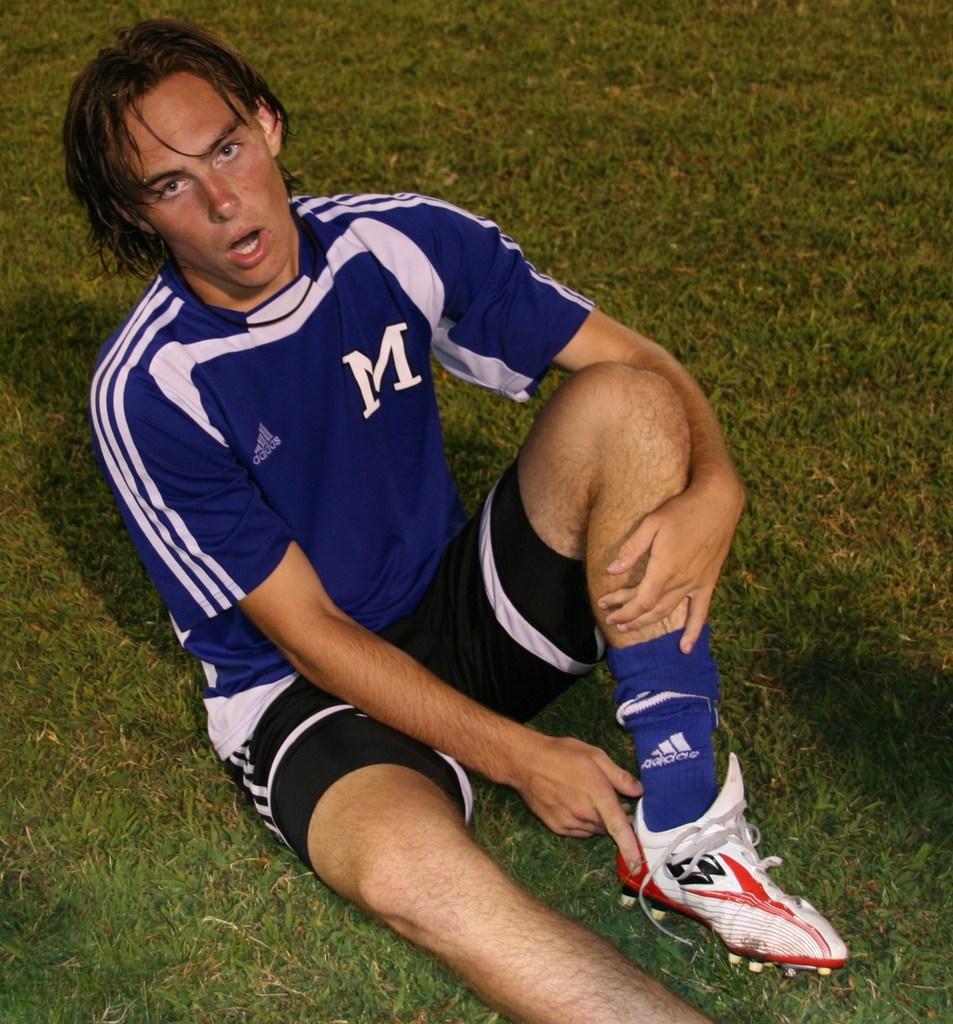Can you describe this image briefly? In this image we see a person sitting on a ground. 